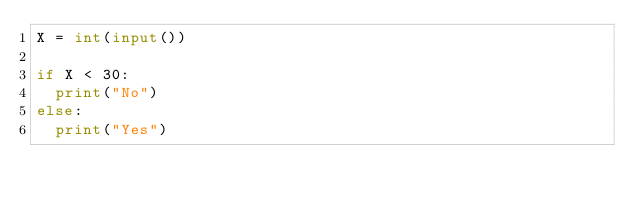<code> <loc_0><loc_0><loc_500><loc_500><_Python_>X = int(input())

if X < 30:
  print("No")
else:
  print("Yes")</code> 